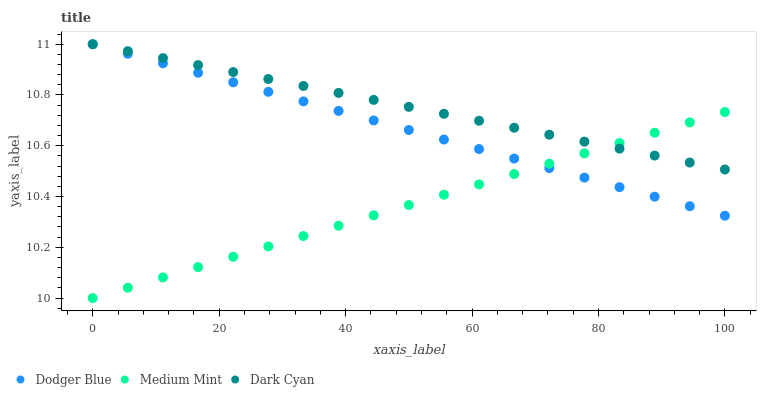Does Medium Mint have the minimum area under the curve?
Answer yes or no. Yes. Does Dark Cyan have the maximum area under the curve?
Answer yes or no. Yes. Does Dodger Blue have the minimum area under the curve?
Answer yes or no. No. Does Dodger Blue have the maximum area under the curve?
Answer yes or no. No. Is Dark Cyan the smoothest?
Answer yes or no. Yes. Is Dodger Blue the roughest?
Answer yes or no. Yes. Is Dodger Blue the smoothest?
Answer yes or no. No. Is Dark Cyan the roughest?
Answer yes or no. No. Does Medium Mint have the lowest value?
Answer yes or no. Yes. Does Dodger Blue have the lowest value?
Answer yes or no. No. Does Dodger Blue have the highest value?
Answer yes or no. Yes. Does Medium Mint intersect Dodger Blue?
Answer yes or no. Yes. Is Medium Mint less than Dodger Blue?
Answer yes or no. No. Is Medium Mint greater than Dodger Blue?
Answer yes or no. No. 